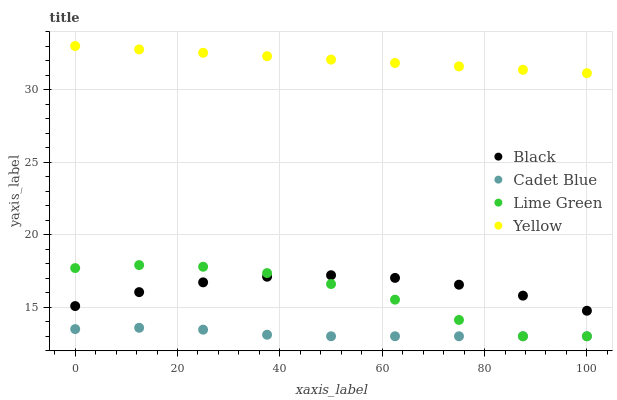Does Cadet Blue have the minimum area under the curve?
Answer yes or no. Yes. Does Yellow have the maximum area under the curve?
Answer yes or no. Yes. Does Black have the minimum area under the curve?
Answer yes or no. No. Does Black have the maximum area under the curve?
Answer yes or no. No. Is Yellow the smoothest?
Answer yes or no. Yes. Is Lime Green the roughest?
Answer yes or no. Yes. Is Cadet Blue the smoothest?
Answer yes or no. No. Is Cadet Blue the roughest?
Answer yes or no. No. Does Lime Green have the lowest value?
Answer yes or no. Yes. Does Black have the lowest value?
Answer yes or no. No. Does Yellow have the highest value?
Answer yes or no. Yes. Does Black have the highest value?
Answer yes or no. No. Is Black less than Yellow?
Answer yes or no. Yes. Is Yellow greater than Cadet Blue?
Answer yes or no. Yes. Does Black intersect Lime Green?
Answer yes or no. Yes. Is Black less than Lime Green?
Answer yes or no. No. Is Black greater than Lime Green?
Answer yes or no. No. Does Black intersect Yellow?
Answer yes or no. No. 